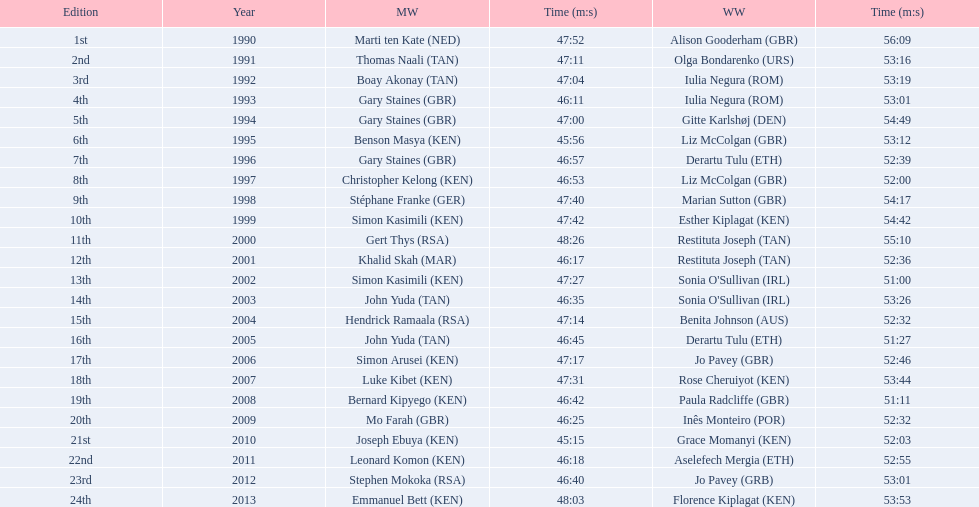What are the names of each male winner? Marti ten Kate (NED), Thomas Naali (TAN), Boay Akonay (TAN), Gary Staines (GBR), Gary Staines (GBR), Benson Masya (KEN), Gary Staines (GBR), Christopher Kelong (KEN), Stéphane Franke (GER), Simon Kasimili (KEN), Gert Thys (RSA), Khalid Skah (MAR), Simon Kasimili (KEN), John Yuda (TAN), Hendrick Ramaala (RSA), John Yuda (TAN), Simon Arusei (KEN), Luke Kibet (KEN), Bernard Kipyego (KEN), Mo Farah (GBR), Joseph Ebuya (KEN), Leonard Komon (KEN), Stephen Mokoka (RSA), Emmanuel Bett (KEN). When did they race? 1990, 1991, 1992, 1993, 1994, 1995, 1996, 1997, 1998, 1999, 2000, 2001, 2002, 2003, 2004, 2005, 2006, 2007, 2008, 2009, 2010, 2011, 2012, 2013. And what were their times? 47:52, 47:11, 47:04, 46:11, 47:00, 45:56, 46:57, 46:53, 47:40, 47:42, 48:26, 46:17, 47:27, 46:35, 47:14, 46:45, 47:17, 47:31, 46:42, 46:25, 45:15, 46:18, 46:40, 48:03. Of those times, which athlete had the fastest time? Joseph Ebuya (KEN). 